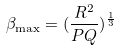Convert formula to latex. <formula><loc_0><loc_0><loc_500><loc_500>\beta _ { \max } = ( \frac { R ^ { 2 } } { P Q } ) ^ { \frac { 1 } { 3 } }</formula> 